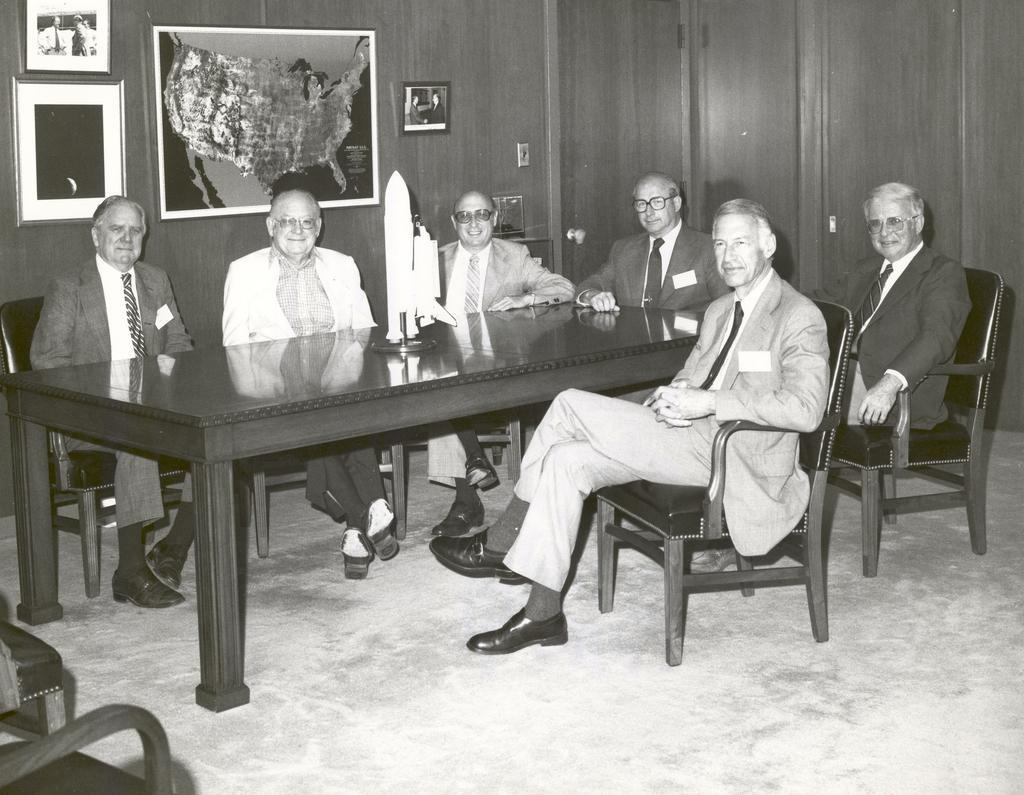In one or two sentences, can you explain what this image depicts? In this image there are chairs and table. There is a rocket like object on the table. There are people sitting. There is a wall. There are few photos on the wall. 